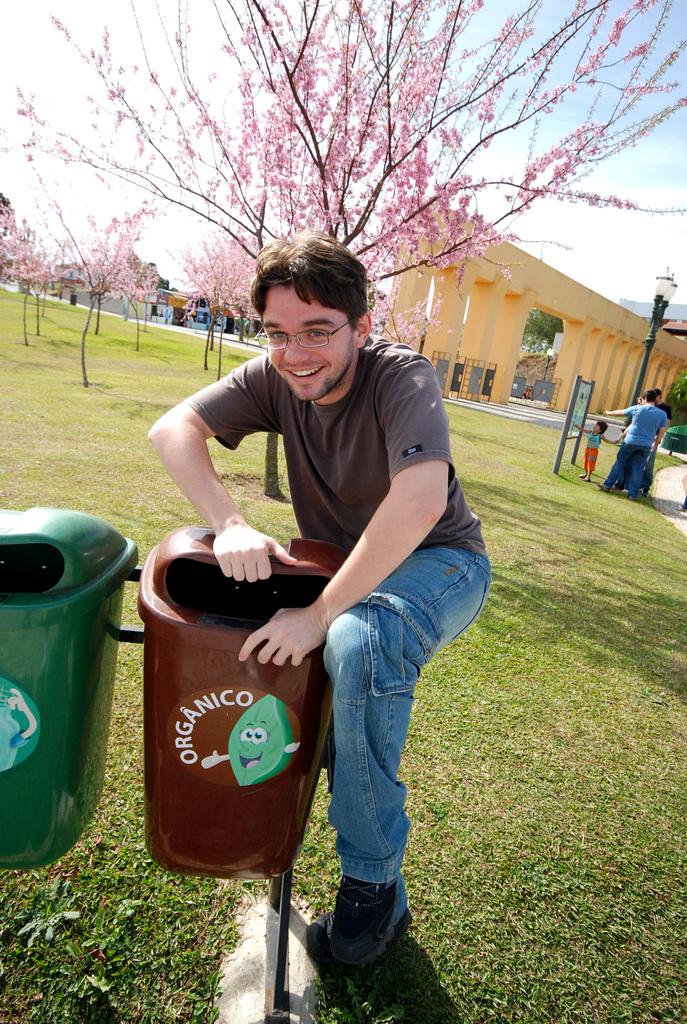What type of bin is the guy grabbing with his hands?
Your response must be concise. Organico. 